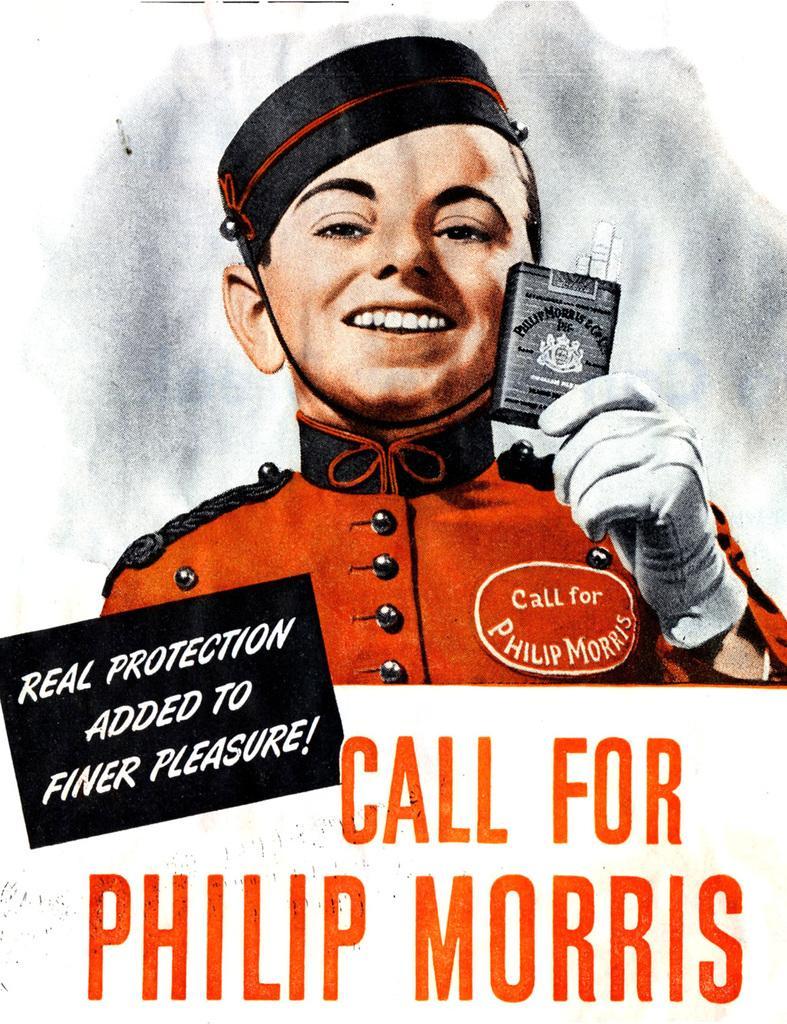Please provide a concise description of this image. This is a poster. In this poster there is a person wearing a cap and glove is holding something. Also something is written on the image. 